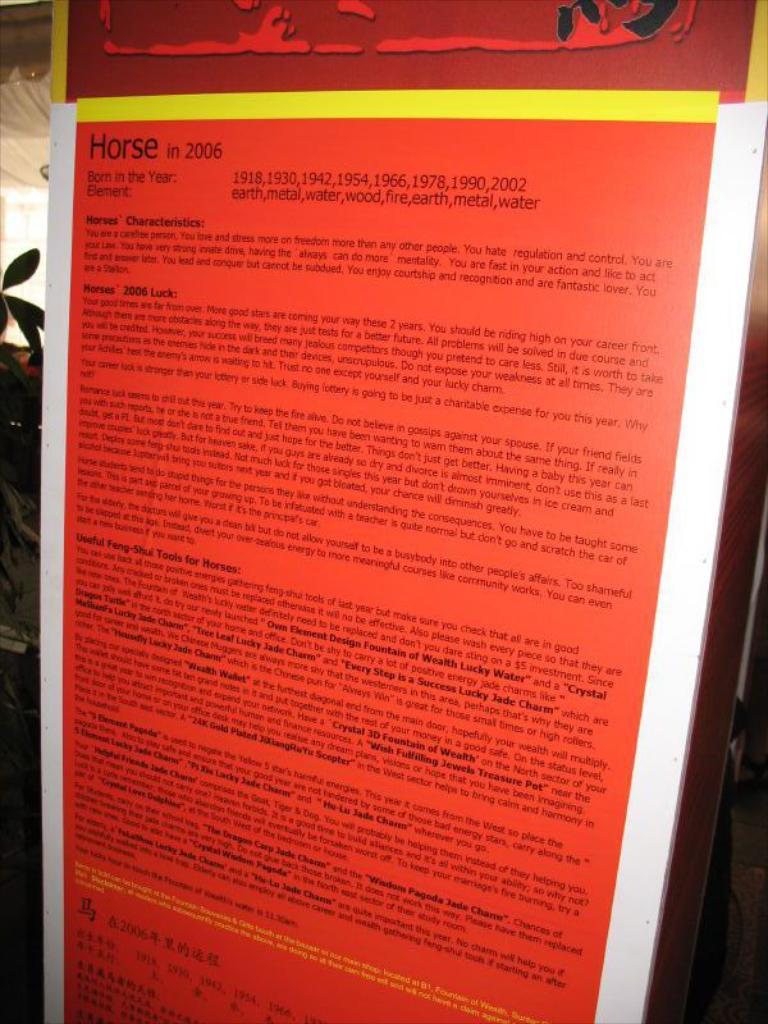<image>
Provide a brief description of the given image. A red poster from the year 2006 about horses. 